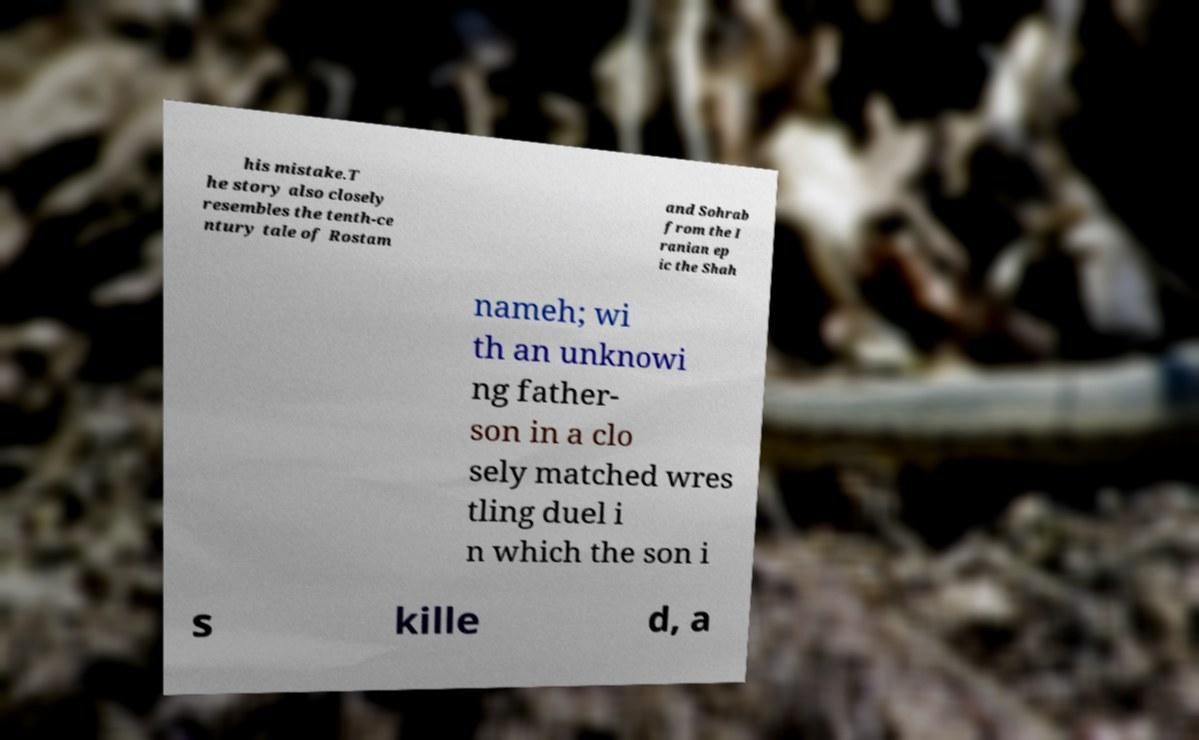There's text embedded in this image that I need extracted. Can you transcribe it verbatim? his mistake.T he story also closely resembles the tenth-ce ntury tale of Rostam and Sohrab from the I ranian ep ic the Shah nameh; wi th an unknowi ng father- son in a clo sely matched wres tling duel i n which the son i s kille d, a 